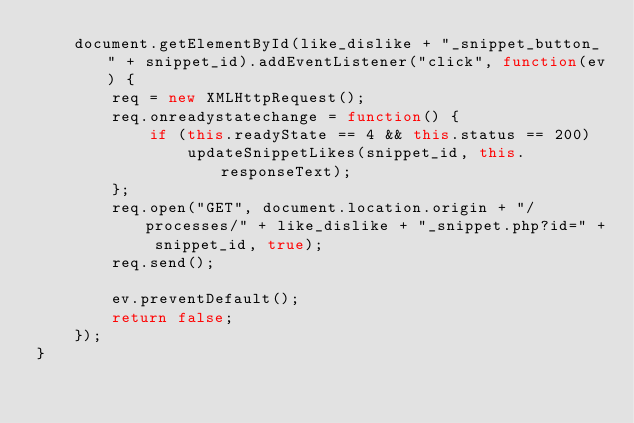Convert code to text. <code><loc_0><loc_0><loc_500><loc_500><_JavaScript_>    document.getElementById(like_dislike + "_snippet_button_" + snippet_id).addEventListener("click", function(ev) {
        req = new XMLHttpRequest();
        req.onreadystatechange = function() {
            if (this.readyState == 4 && this.status == 200)
                updateSnippetLikes(snippet_id, this.responseText);
        };
        req.open("GET", document.location.origin + "/processes/" + like_dislike + "_snippet.php?id=" + snippet_id, true);
        req.send();

        ev.preventDefault();
        return false;
    });
}</code> 